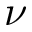<formula> <loc_0><loc_0><loc_500><loc_500>\nu</formula> 